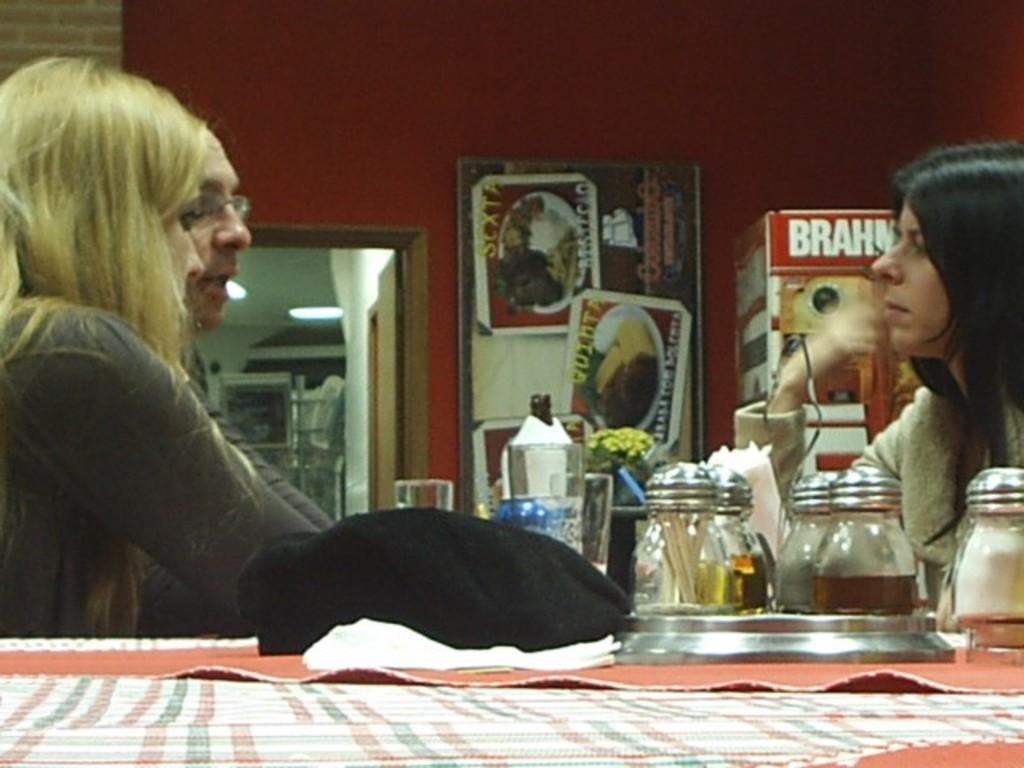Describe this image in one or two sentences. This Image is clicked inside. There are three people in this image two women and one man. One woman is sitting on the right side and one woman is sitting on the left side. Man is sitting on the left side. There is a door in the middle, there is table in the bottom on the table there are clothes, glasses, boxes. 